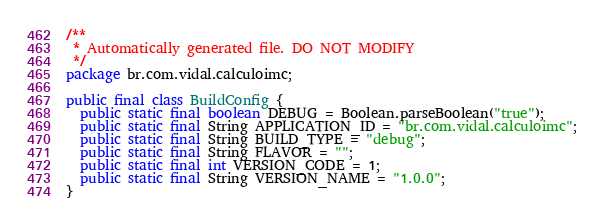<code> <loc_0><loc_0><loc_500><loc_500><_Java_>/**
 * Automatically generated file. DO NOT MODIFY
 */
package br.com.vidal.calculoimc;

public final class BuildConfig {
  public static final boolean DEBUG = Boolean.parseBoolean("true");
  public static final String APPLICATION_ID = "br.com.vidal.calculoimc";
  public static final String BUILD_TYPE = "debug";
  public static final String FLAVOR = "";
  public static final int VERSION_CODE = 1;
  public static final String VERSION_NAME = "1.0.0";
}
</code> 